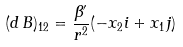Convert formula to latex. <formula><loc_0><loc_0><loc_500><loc_500>( d \, B ) _ { 1 2 } = \frac { \beta ^ { \prime } } { r ^ { 2 } } ( - x _ { 2 } i + x _ { 1 } j )</formula> 